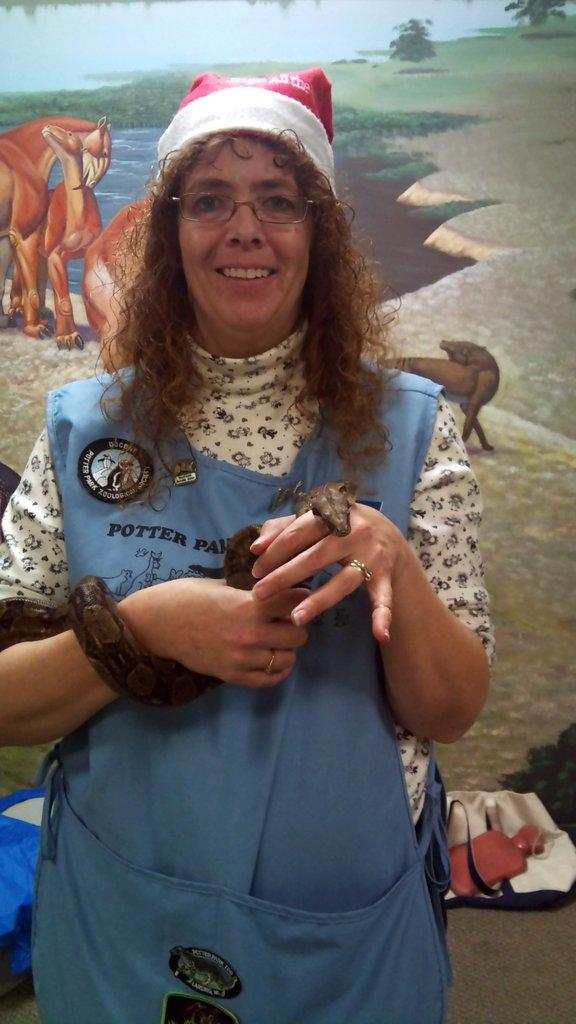Who is present in the image? There is a woman in the image. What is the woman doing in the image? The woman is standing and smiling in the image. What is the woman holding in the image? The woman is holding a snake in the image. What can be seen in the background of the image? There is a wall in the background of the image, and a painting is on the wall. What type of frame is around the painting in the image? There is no frame mentioned or visible around the painting in the image. 